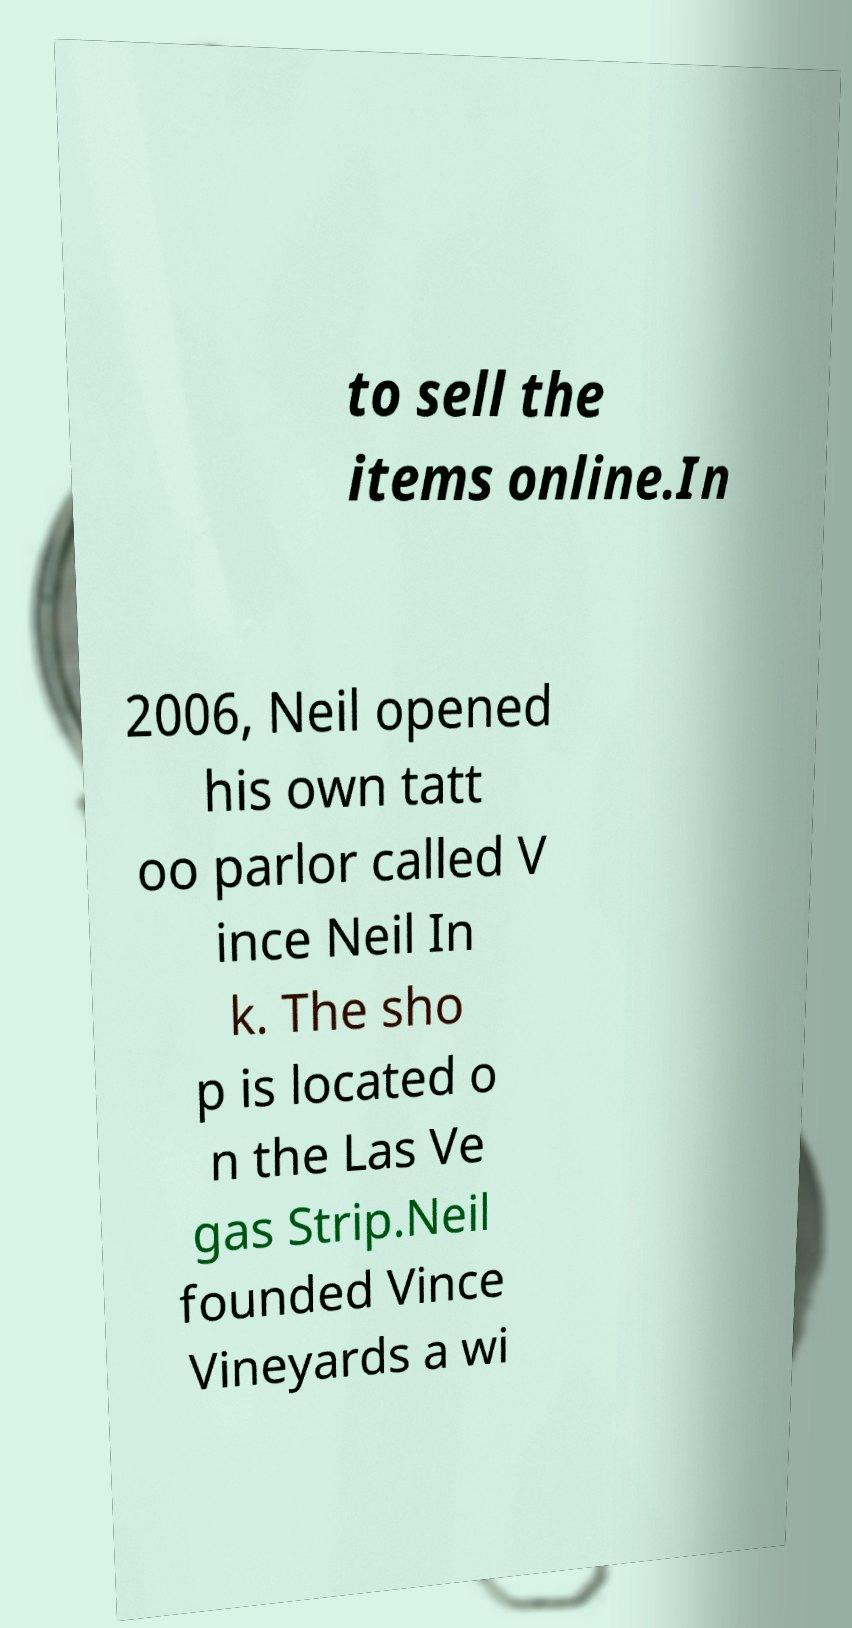Can you read and provide the text displayed in the image?This photo seems to have some interesting text. Can you extract and type it out for me? to sell the items online.In 2006, Neil opened his own tatt oo parlor called V ince Neil In k. The sho p is located o n the Las Ve gas Strip.Neil founded Vince Vineyards a wi 